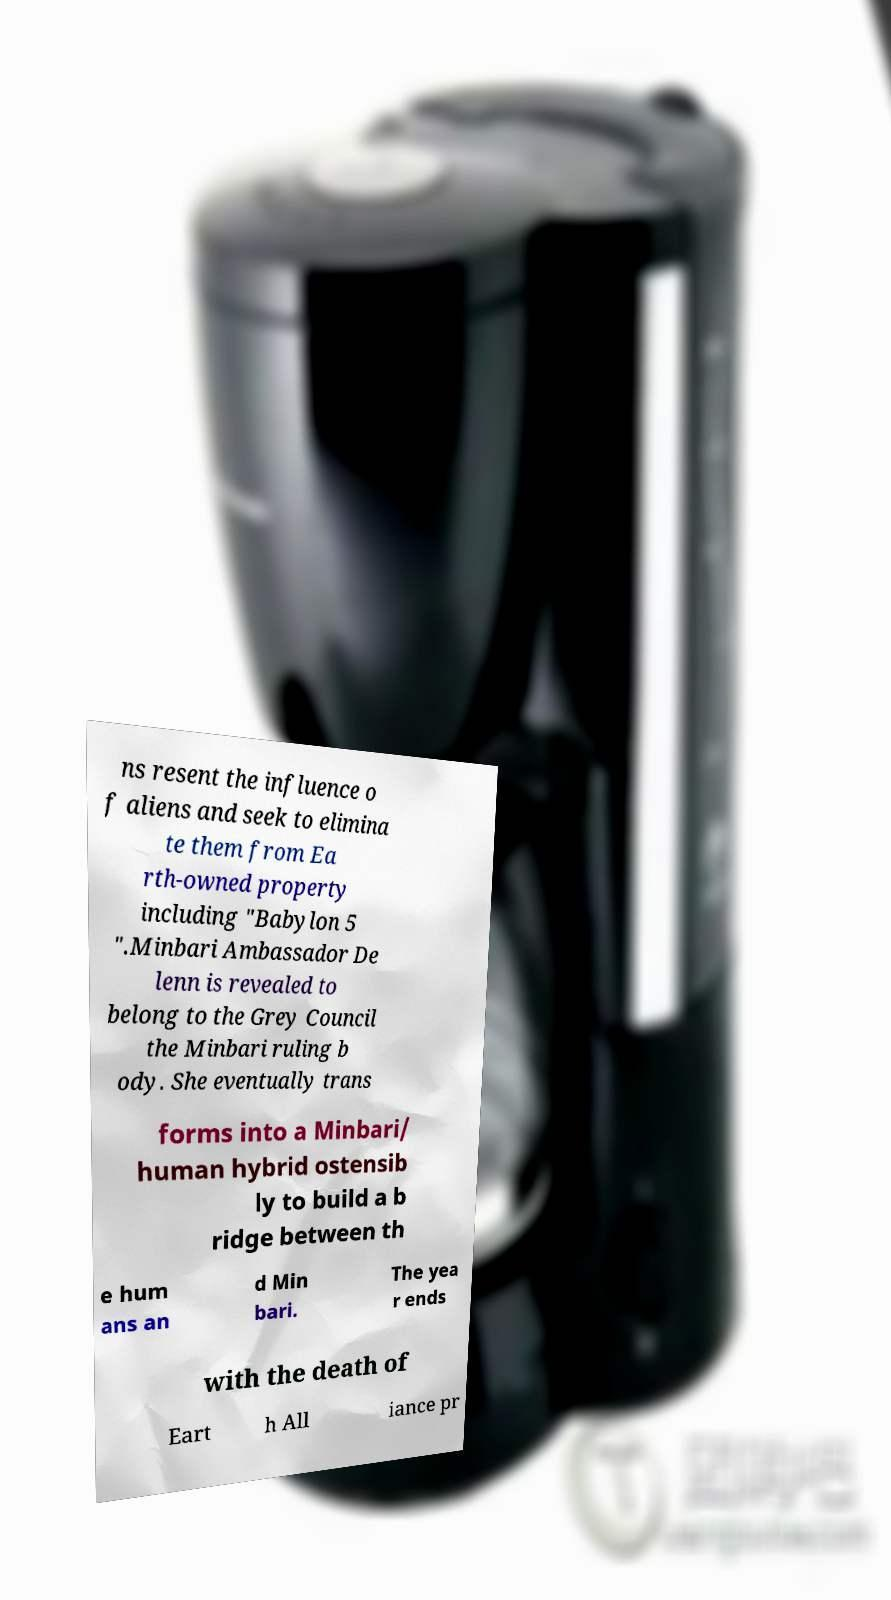I need the written content from this picture converted into text. Can you do that? ns resent the influence o f aliens and seek to elimina te them from Ea rth-owned property including "Babylon 5 ".Minbari Ambassador De lenn is revealed to belong to the Grey Council the Minbari ruling b ody. She eventually trans forms into a Minbari/ human hybrid ostensib ly to build a b ridge between th e hum ans an d Min bari. The yea r ends with the death of Eart h All iance pr 